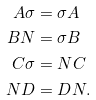Convert formula to latex. <formula><loc_0><loc_0><loc_500><loc_500>A \sigma & = \sigma A \\ B N & = \sigma B \\ C \sigma & = N C \\ N D & = D N .</formula> 